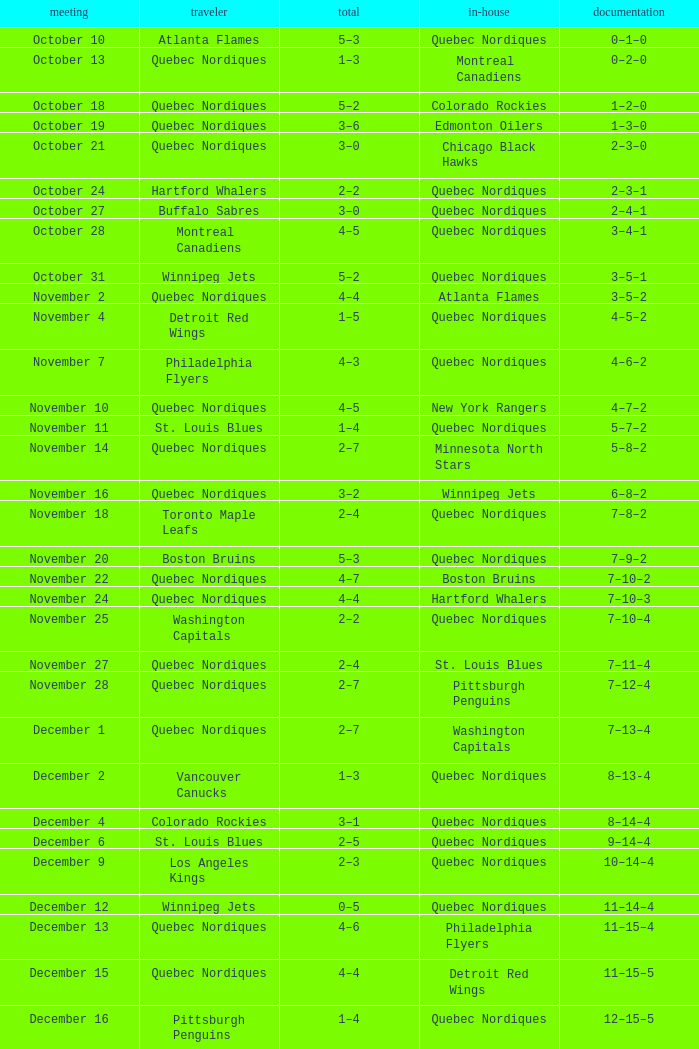Which Home has a Record of 16–17–6? Toronto Maple Leafs. 